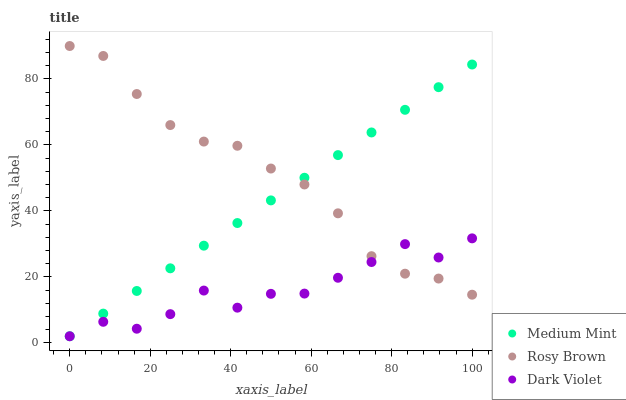Does Dark Violet have the minimum area under the curve?
Answer yes or no. Yes. Does Rosy Brown have the maximum area under the curve?
Answer yes or no. Yes. Does Rosy Brown have the minimum area under the curve?
Answer yes or no. No. Does Dark Violet have the maximum area under the curve?
Answer yes or no. No. Is Medium Mint the smoothest?
Answer yes or no. Yes. Is Dark Violet the roughest?
Answer yes or no. Yes. Is Rosy Brown the smoothest?
Answer yes or no. No. Is Rosy Brown the roughest?
Answer yes or no. No. Does Medium Mint have the lowest value?
Answer yes or no. Yes. Does Rosy Brown have the lowest value?
Answer yes or no. No. Does Rosy Brown have the highest value?
Answer yes or no. Yes. Does Dark Violet have the highest value?
Answer yes or no. No. Does Medium Mint intersect Rosy Brown?
Answer yes or no. Yes. Is Medium Mint less than Rosy Brown?
Answer yes or no. No. Is Medium Mint greater than Rosy Brown?
Answer yes or no. No. 